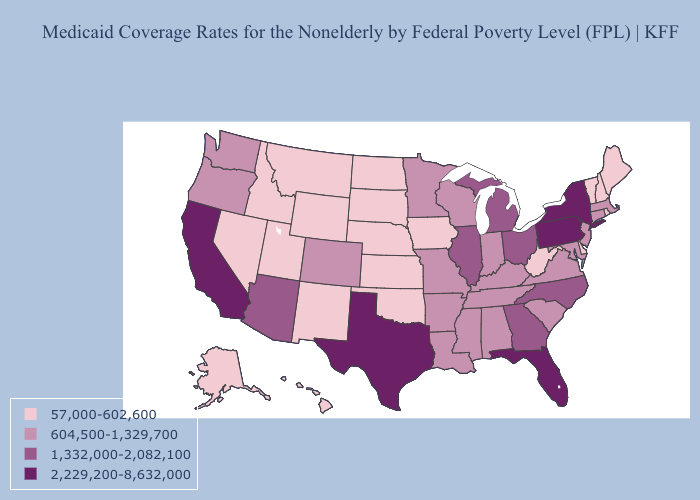Among the states that border Alabama , which have the highest value?
Short answer required. Florida. What is the highest value in the Northeast ?
Be succinct. 2,229,200-8,632,000. Does New York have the highest value in the Northeast?
Keep it brief. Yes. Does Rhode Island have the lowest value in the Northeast?
Short answer required. Yes. What is the value of Delaware?
Answer briefly. 57,000-602,600. What is the value of Kansas?
Write a very short answer. 57,000-602,600. What is the value of Mississippi?
Short answer required. 604,500-1,329,700. What is the value of Alaska?
Concise answer only. 57,000-602,600. What is the value of Texas?
Be succinct. 2,229,200-8,632,000. Does Maine have the lowest value in the USA?
Quick response, please. Yes. Is the legend a continuous bar?
Keep it brief. No. Among the states that border Vermont , which have the highest value?
Keep it brief. New York. Does West Virginia have the same value as South Carolina?
Write a very short answer. No. Does New Mexico have the highest value in the USA?
Concise answer only. No. Name the states that have a value in the range 604,500-1,329,700?
Keep it brief. Alabama, Arkansas, Colorado, Connecticut, Indiana, Kentucky, Louisiana, Maryland, Massachusetts, Minnesota, Mississippi, Missouri, New Jersey, Oregon, South Carolina, Tennessee, Virginia, Washington, Wisconsin. 